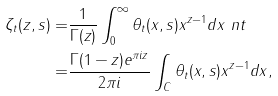<formula> <loc_0><loc_0><loc_500><loc_500>\zeta _ { t } ( z , s ) = & \frac { 1 } { \Gamma ( z ) } \int _ { 0 } ^ { \infty } \theta _ { t } ( x , s ) x ^ { z - 1 } d x \ n t \\ = & \frac { \Gamma ( 1 - z ) e ^ { \pi i z } } { 2 \pi i } \int _ { C } \theta _ { t } ( x , s ) x ^ { z - 1 } d x ,</formula> 